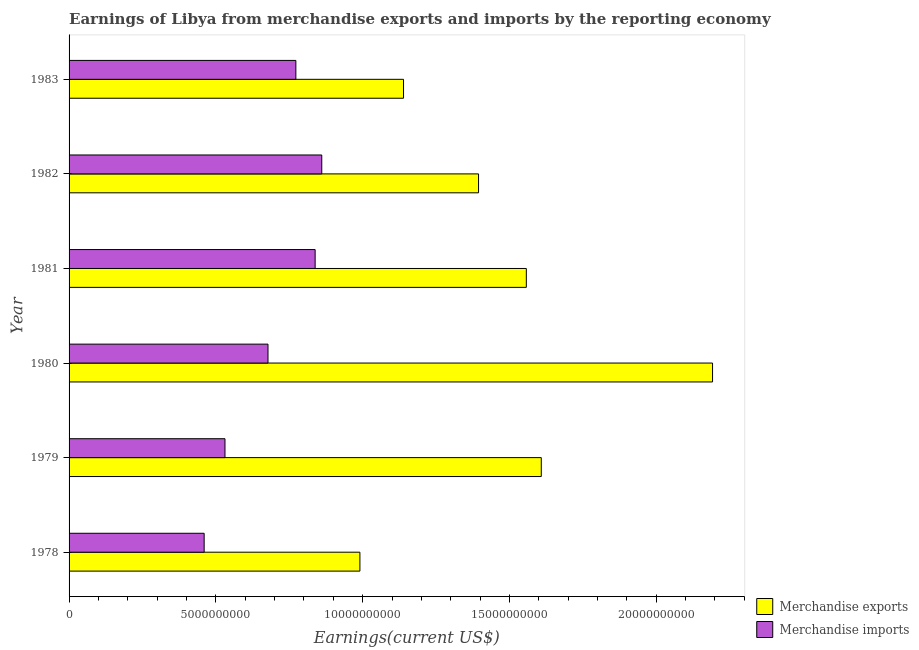Are the number of bars per tick equal to the number of legend labels?
Offer a very short reply. Yes. Are the number of bars on each tick of the Y-axis equal?
Offer a very short reply. Yes. How many bars are there on the 6th tick from the top?
Your answer should be compact. 2. How many bars are there on the 6th tick from the bottom?
Ensure brevity in your answer.  2. What is the label of the 6th group of bars from the top?
Offer a terse response. 1978. In how many cases, is the number of bars for a given year not equal to the number of legend labels?
Your answer should be compact. 0. What is the earnings from merchandise imports in 1978?
Your answer should be very brief. 4.60e+09. Across all years, what is the maximum earnings from merchandise exports?
Give a very brief answer. 2.19e+1. Across all years, what is the minimum earnings from merchandise imports?
Your answer should be very brief. 4.60e+09. In which year was the earnings from merchandise exports maximum?
Your answer should be very brief. 1980. In which year was the earnings from merchandise imports minimum?
Your answer should be compact. 1978. What is the total earnings from merchandise imports in the graph?
Your response must be concise. 4.14e+1. What is the difference between the earnings from merchandise imports in 1979 and that in 1980?
Offer a terse response. -1.46e+09. What is the difference between the earnings from merchandise exports in 1980 and the earnings from merchandise imports in 1983?
Offer a very short reply. 1.42e+1. What is the average earnings from merchandise exports per year?
Provide a succinct answer. 1.48e+1. In the year 1980, what is the difference between the earnings from merchandise exports and earnings from merchandise imports?
Provide a short and direct response. 1.51e+1. What is the ratio of the earnings from merchandise imports in 1978 to that in 1981?
Provide a short and direct response. 0.55. Is the difference between the earnings from merchandise exports in 1979 and 1983 greater than the difference between the earnings from merchandise imports in 1979 and 1983?
Give a very brief answer. Yes. What is the difference between the highest and the second highest earnings from merchandise imports?
Ensure brevity in your answer.  2.26e+08. What is the difference between the highest and the lowest earnings from merchandise exports?
Provide a short and direct response. 1.20e+1. Is the sum of the earnings from merchandise exports in 1979 and 1980 greater than the maximum earnings from merchandise imports across all years?
Keep it short and to the point. Yes. How many bars are there?
Give a very brief answer. 12. How many years are there in the graph?
Offer a terse response. 6. What is the difference between two consecutive major ticks on the X-axis?
Ensure brevity in your answer.  5.00e+09. Are the values on the major ticks of X-axis written in scientific E-notation?
Give a very brief answer. No. Does the graph contain any zero values?
Your answer should be compact. No. Where does the legend appear in the graph?
Offer a very short reply. Bottom right. How are the legend labels stacked?
Offer a terse response. Vertical. What is the title of the graph?
Give a very brief answer. Earnings of Libya from merchandise exports and imports by the reporting economy. What is the label or title of the X-axis?
Offer a very short reply. Earnings(current US$). What is the Earnings(current US$) of Merchandise exports in 1978?
Ensure brevity in your answer.  9.91e+09. What is the Earnings(current US$) in Merchandise imports in 1978?
Your response must be concise. 4.60e+09. What is the Earnings(current US$) of Merchandise exports in 1979?
Provide a succinct answer. 1.61e+1. What is the Earnings(current US$) of Merchandise imports in 1979?
Give a very brief answer. 5.31e+09. What is the Earnings(current US$) in Merchandise exports in 1980?
Provide a short and direct response. 2.19e+1. What is the Earnings(current US$) of Merchandise imports in 1980?
Offer a terse response. 6.78e+09. What is the Earnings(current US$) in Merchandise exports in 1981?
Offer a terse response. 1.56e+1. What is the Earnings(current US$) of Merchandise imports in 1981?
Your response must be concise. 8.38e+09. What is the Earnings(current US$) in Merchandise exports in 1982?
Your response must be concise. 1.39e+1. What is the Earnings(current US$) in Merchandise imports in 1982?
Offer a very short reply. 8.61e+09. What is the Earnings(current US$) of Merchandise exports in 1983?
Make the answer very short. 1.14e+1. What is the Earnings(current US$) of Merchandise imports in 1983?
Your response must be concise. 7.73e+09. Across all years, what is the maximum Earnings(current US$) in Merchandise exports?
Ensure brevity in your answer.  2.19e+1. Across all years, what is the maximum Earnings(current US$) of Merchandise imports?
Give a very brief answer. 8.61e+09. Across all years, what is the minimum Earnings(current US$) of Merchandise exports?
Offer a very short reply. 9.91e+09. Across all years, what is the minimum Earnings(current US$) of Merchandise imports?
Offer a terse response. 4.60e+09. What is the total Earnings(current US$) in Merchandise exports in the graph?
Make the answer very short. 8.88e+1. What is the total Earnings(current US$) of Merchandise imports in the graph?
Give a very brief answer. 4.14e+1. What is the difference between the Earnings(current US$) in Merchandise exports in 1978 and that in 1979?
Give a very brief answer. -6.18e+09. What is the difference between the Earnings(current US$) in Merchandise imports in 1978 and that in 1979?
Ensure brevity in your answer.  -7.10e+08. What is the difference between the Earnings(current US$) in Merchandise exports in 1978 and that in 1980?
Your answer should be compact. -1.20e+1. What is the difference between the Earnings(current US$) in Merchandise imports in 1978 and that in 1980?
Provide a short and direct response. -2.17e+09. What is the difference between the Earnings(current US$) in Merchandise exports in 1978 and that in 1981?
Keep it short and to the point. -5.67e+09. What is the difference between the Earnings(current US$) of Merchandise imports in 1978 and that in 1981?
Your answer should be compact. -3.78e+09. What is the difference between the Earnings(current US$) of Merchandise exports in 1978 and that in 1982?
Your response must be concise. -4.04e+09. What is the difference between the Earnings(current US$) in Merchandise imports in 1978 and that in 1982?
Your answer should be very brief. -4.01e+09. What is the difference between the Earnings(current US$) of Merchandise exports in 1978 and that in 1983?
Keep it short and to the point. -1.48e+09. What is the difference between the Earnings(current US$) in Merchandise imports in 1978 and that in 1983?
Your response must be concise. -3.12e+09. What is the difference between the Earnings(current US$) of Merchandise exports in 1979 and that in 1980?
Your answer should be very brief. -5.83e+09. What is the difference between the Earnings(current US$) of Merchandise imports in 1979 and that in 1980?
Ensure brevity in your answer.  -1.46e+09. What is the difference between the Earnings(current US$) of Merchandise exports in 1979 and that in 1981?
Offer a terse response. 5.09e+08. What is the difference between the Earnings(current US$) in Merchandise imports in 1979 and that in 1981?
Keep it short and to the point. -3.07e+09. What is the difference between the Earnings(current US$) of Merchandise exports in 1979 and that in 1982?
Your answer should be very brief. 2.14e+09. What is the difference between the Earnings(current US$) in Merchandise imports in 1979 and that in 1982?
Your answer should be compact. -3.30e+09. What is the difference between the Earnings(current US$) in Merchandise exports in 1979 and that in 1983?
Make the answer very short. 4.69e+09. What is the difference between the Earnings(current US$) in Merchandise imports in 1979 and that in 1983?
Make the answer very short. -2.41e+09. What is the difference between the Earnings(current US$) of Merchandise exports in 1980 and that in 1981?
Your answer should be compact. 6.34e+09. What is the difference between the Earnings(current US$) in Merchandise imports in 1980 and that in 1981?
Give a very brief answer. -1.61e+09. What is the difference between the Earnings(current US$) of Merchandise exports in 1980 and that in 1982?
Offer a terse response. 7.97e+09. What is the difference between the Earnings(current US$) in Merchandise imports in 1980 and that in 1982?
Offer a terse response. -1.83e+09. What is the difference between the Earnings(current US$) of Merchandise exports in 1980 and that in 1983?
Your response must be concise. 1.05e+1. What is the difference between the Earnings(current US$) of Merchandise imports in 1980 and that in 1983?
Offer a very short reply. -9.49e+08. What is the difference between the Earnings(current US$) of Merchandise exports in 1981 and that in 1982?
Give a very brief answer. 1.63e+09. What is the difference between the Earnings(current US$) in Merchandise imports in 1981 and that in 1982?
Your answer should be very brief. -2.26e+08. What is the difference between the Earnings(current US$) in Merchandise exports in 1981 and that in 1983?
Your answer should be compact. 4.18e+09. What is the difference between the Earnings(current US$) in Merchandise imports in 1981 and that in 1983?
Your response must be concise. 6.56e+08. What is the difference between the Earnings(current US$) of Merchandise exports in 1982 and that in 1983?
Ensure brevity in your answer.  2.56e+09. What is the difference between the Earnings(current US$) of Merchandise imports in 1982 and that in 1983?
Make the answer very short. 8.83e+08. What is the difference between the Earnings(current US$) in Merchandise exports in 1978 and the Earnings(current US$) in Merchandise imports in 1979?
Provide a succinct answer. 4.60e+09. What is the difference between the Earnings(current US$) of Merchandise exports in 1978 and the Earnings(current US$) of Merchandise imports in 1980?
Your answer should be very brief. 3.13e+09. What is the difference between the Earnings(current US$) in Merchandise exports in 1978 and the Earnings(current US$) in Merchandise imports in 1981?
Make the answer very short. 1.52e+09. What is the difference between the Earnings(current US$) in Merchandise exports in 1978 and the Earnings(current US$) in Merchandise imports in 1982?
Provide a succinct answer. 1.30e+09. What is the difference between the Earnings(current US$) of Merchandise exports in 1978 and the Earnings(current US$) of Merchandise imports in 1983?
Keep it short and to the point. 2.18e+09. What is the difference between the Earnings(current US$) in Merchandise exports in 1979 and the Earnings(current US$) in Merchandise imports in 1980?
Ensure brevity in your answer.  9.31e+09. What is the difference between the Earnings(current US$) in Merchandise exports in 1979 and the Earnings(current US$) in Merchandise imports in 1981?
Keep it short and to the point. 7.70e+09. What is the difference between the Earnings(current US$) in Merchandise exports in 1979 and the Earnings(current US$) in Merchandise imports in 1982?
Your response must be concise. 7.48e+09. What is the difference between the Earnings(current US$) of Merchandise exports in 1979 and the Earnings(current US$) of Merchandise imports in 1983?
Your answer should be very brief. 8.36e+09. What is the difference between the Earnings(current US$) of Merchandise exports in 1980 and the Earnings(current US$) of Merchandise imports in 1981?
Give a very brief answer. 1.35e+1. What is the difference between the Earnings(current US$) in Merchandise exports in 1980 and the Earnings(current US$) in Merchandise imports in 1982?
Offer a terse response. 1.33e+1. What is the difference between the Earnings(current US$) in Merchandise exports in 1980 and the Earnings(current US$) in Merchandise imports in 1983?
Your answer should be very brief. 1.42e+1. What is the difference between the Earnings(current US$) in Merchandise exports in 1981 and the Earnings(current US$) in Merchandise imports in 1982?
Provide a short and direct response. 6.97e+09. What is the difference between the Earnings(current US$) in Merchandise exports in 1981 and the Earnings(current US$) in Merchandise imports in 1983?
Provide a succinct answer. 7.85e+09. What is the difference between the Earnings(current US$) in Merchandise exports in 1982 and the Earnings(current US$) in Merchandise imports in 1983?
Offer a very short reply. 6.22e+09. What is the average Earnings(current US$) of Merchandise exports per year?
Give a very brief answer. 1.48e+1. What is the average Earnings(current US$) in Merchandise imports per year?
Keep it short and to the point. 6.90e+09. In the year 1978, what is the difference between the Earnings(current US$) in Merchandise exports and Earnings(current US$) in Merchandise imports?
Offer a terse response. 5.31e+09. In the year 1979, what is the difference between the Earnings(current US$) in Merchandise exports and Earnings(current US$) in Merchandise imports?
Make the answer very short. 1.08e+1. In the year 1980, what is the difference between the Earnings(current US$) of Merchandise exports and Earnings(current US$) of Merchandise imports?
Your response must be concise. 1.51e+1. In the year 1981, what is the difference between the Earnings(current US$) of Merchandise exports and Earnings(current US$) of Merchandise imports?
Offer a terse response. 7.19e+09. In the year 1982, what is the difference between the Earnings(current US$) in Merchandise exports and Earnings(current US$) in Merchandise imports?
Provide a short and direct response. 5.34e+09. In the year 1983, what is the difference between the Earnings(current US$) of Merchandise exports and Earnings(current US$) of Merchandise imports?
Your answer should be very brief. 3.67e+09. What is the ratio of the Earnings(current US$) in Merchandise exports in 1978 to that in 1979?
Offer a terse response. 0.62. What is the ratio of the Earnings(current US$) in Merchandise imports in 1978 to that in 1979?
Make the answer very short. 0.87. What is the ratio of the Earnings(current US$) of Merchandise exports in 1978 to that in 1980?
Offer a terse response. 0.45. What is the ratio of the Earnings(current US$) in Merchandise imports in 1978 to that in 1980?
Offer a very short reply. 0.68. What is the ratio of the Earnings(current US$) in Merchandise exports in 1978 to that in 1981?
Give a very brief answer. 0.64. What is the ratio of the Earnings(current US$) in Merchandise imports in 1978 to that in 1981?
Ensure brevity in your answer.  0.55. What is the ratio of the Earnings(current US$) in Merchandise exports in 1978 to that in 1982?
Keep it short and to the point. 0.71. What is the ratio of the Earnings(current US$) of Merchandise imports in 1978 to that in 1982?
Your response must be concise. 0.53. What is the ratio of the Earnings(current US$) in Merchandise exports in 1978 to that in 1983?
Keep it short and to the point. 0.87. What is the ratio of the Earnings(current US$) in Merchandise imports in 1978 to that in 1983?
Keep it short and to the point. 0.6. What is the ratio of the Earnings(current US$) in Merchandise exports in 1979 to that in 1980?
Give a very brief answer. 0.73. What is the ratio of the Earnings(current US$) of Merchandise imports in 1979 to that in 1980?
Make the answer very short. 0.78. What is the ratio of the Earnings(current US$) in Merchandise exports in 1979 to that in 1981?
Keep it short and to the point. 1.03. What is the ratio of the Earnings(current US$) in Merchandise imports in 1979 to that in 1981?
Provide a short and direct response. 0.63. What is the ratio of the Earnings(current US$) of Merchandise exports in 1979 to that in 1982?
Provide a succinct answer. 1.15. What is the ratio of the Earnings(current US$) of Merchandise imports in 1979 to that in 1982?
Make the answer very short. 0.62. What is the ratio of the Earnings(current US$) in Merchandise exports in 1979 to that in 1983?
Ensure brevity in your answer.  1.41. What is the ratio of the Earnings(current US$) in Merchandise imports in 1979 to that in 1983?
Provide a short and direct response. 0.69. What is the ratio of the Earnings(current US$) in Merchandise exports in 1980 to that in 1981?
Ensure brevity in your answer.  1.41. What is the ratio of the Earnings(current US$) in Merchandise imports in 1980 to that in 1981?
Make the answer very short. 0.81. What is the ratio of the Earnings(current US$) in Merchandise exports in 1980 to that in 1982?
Your answer should be very brief. 1.57. What is the ratio of the Earnings(current US$) of Merchandise imports in 1980 to that in 1982?
Give a very brief answer. 0.79. What is the ratio of the Earnings(current US$) of Merchandise exports in 1980 to that in 1983?
Give a very brief answer. 1.92. What is the ratio of the Earnings(current US$) of Merchandise imports in 1980 to that in 1983?
Provide a succinct answer. 0.88. What is the ratio of the Earnings(current US$) in Merchandise exports in 1981 to that in 1982?
Keep it short and to the point. 1.12. What is the ratio of the Earnings(current US$) in Merchandise imports in 1981 to that in 1982?
Your answer should be very brief. 0.97. What is the ratio of the Earnings(current US$) in Merchandise exports in 1981 to that in 1983?
Your answer should be compact. 1.37. What is the ratio of the Earnings(current US$) in Merchandise imports in 1981 to that in 1983?
Keep it short and to the point. 1.08. What is the ratio of the Earnings(current US$) in Merchandise exports in 1982 to that in 1983?
Offer a terse response. 1.22. What is the ratio of the Earnings(current US$) in Merchandise imports in 1982 to that in 1983?
Give a very brief answer. 1.11. What is the difference between the highest and the second highest Earnings(current US$) of Merchandise exports?
Keep it short and to the point. 5.83e+09. What is the difference between the highest and the second highest Earnings(current US$) of Merchandise imports?
Make the answer very short. 2.26e+08. What is the difference between the highest and the lowest Earnings(current US$) of Merchandise exports?
Offer a very short reply. 1.20e+1. What is the difference between the highest and the lowest Earnings(current US$) of Merchandise imports?
Your response must be concise. 4.01e+09. 